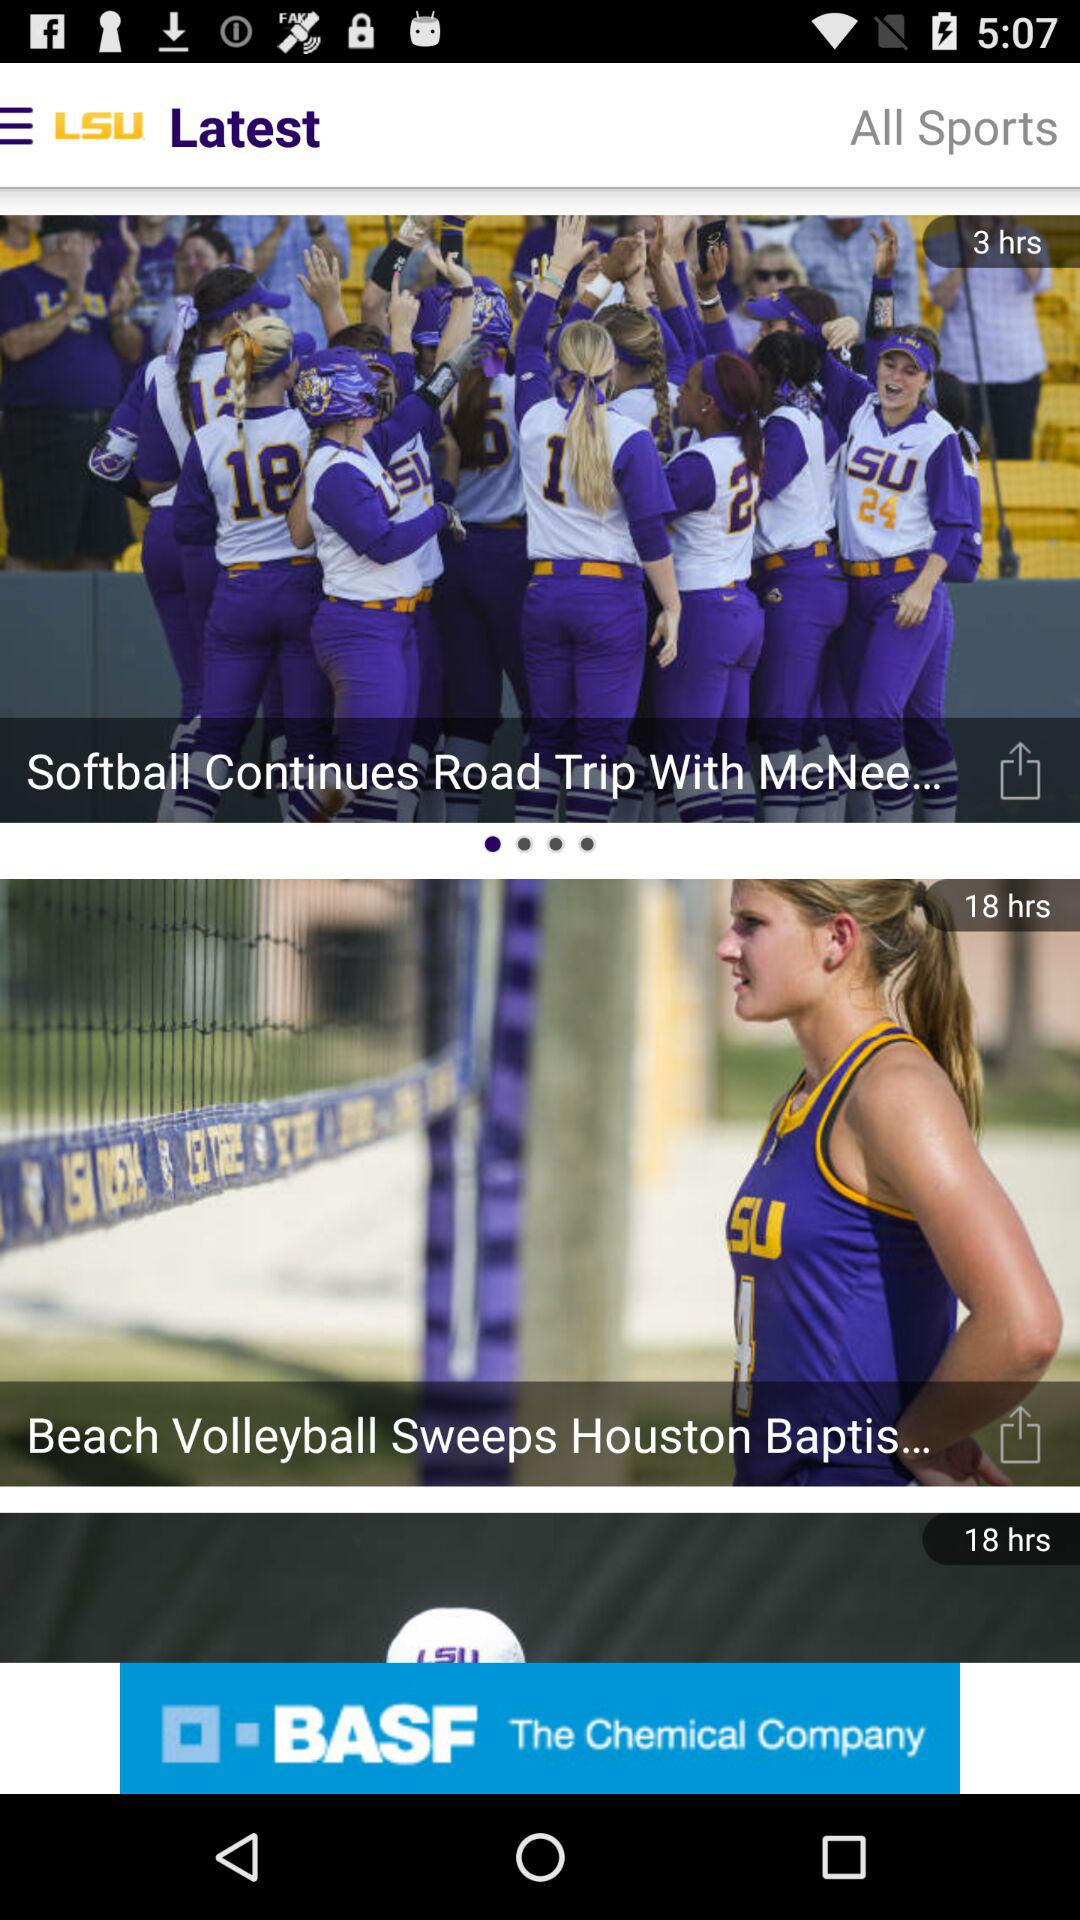What is the video timing of softball continues road trip with mcnee?
When the provided information is insufficient, respond with <no answer>. <no answer> 